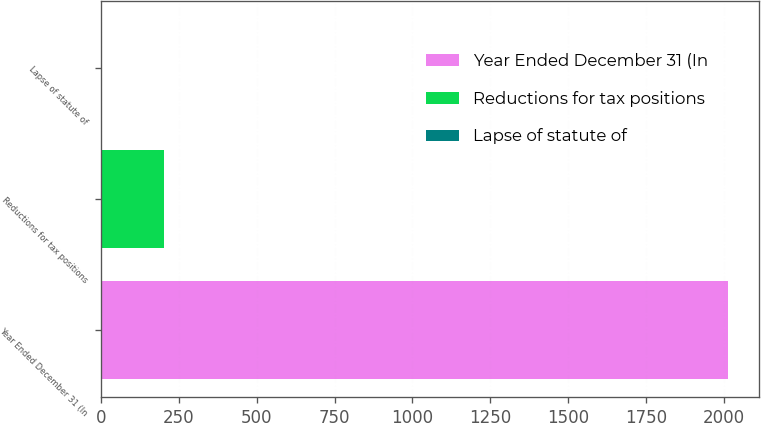Convert chart to OTSL. <chart><loc_0><loc_0><loc_500><loc_500><bar_chart><fcel>Year Ended December 31 (In<fcel>Reductions for tax positions<fcel>Lapse of statute of<nl><fcel>2013<fcel>203.1<fcel>2<nl></chart> 